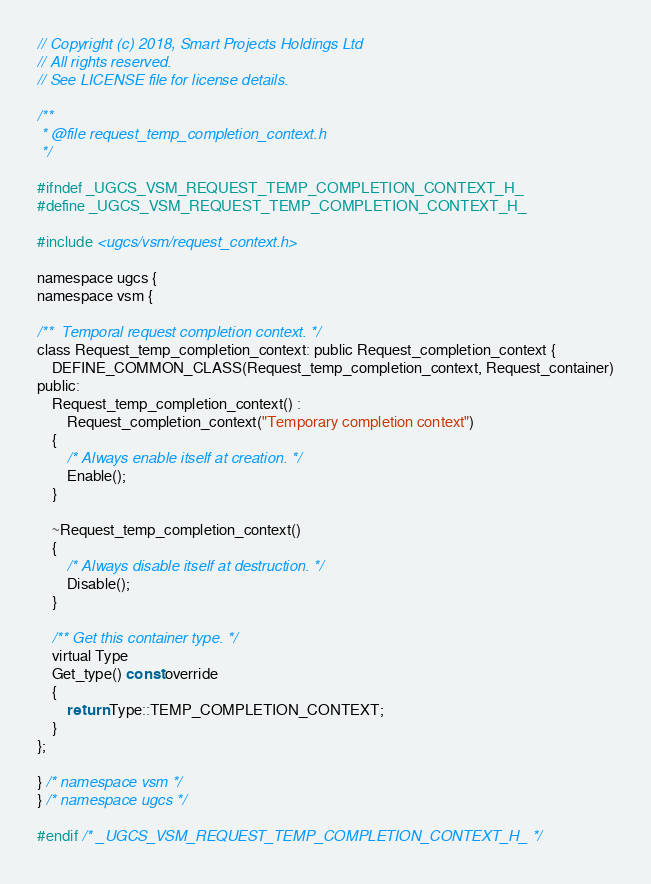Convert code to text. <code><loc_0><loc_0><loc_500><loc_500><_C_>// Copyright (c) 2018, Smart Projects Holdings Ltd
// All rights reserved.
// See LICENSE file for license details.

/**
 * @file request_temp_completion_context.h
 */

#ifndef _UGCS_VSM_REQUEST_TEMP_COMPLETION_CONTEXT_H_
#define _UGCS_VSM_REQUEST_TEMP_COMPLETION_CONTEXT_H_

#include <ugcs/vsm/request_context.h>

namespace ugcs {
namespace vsm {

/**  Temporal request completion context. */
class Request_temp_completion_context: public Request_completion_context {
    DEFINE_COMMON_CLASS(Request_temp_completion_context, Request_container)
public:
    Request_temp_completion_context() :
        Request_completion_context("Temporary completion context")
    {
        /* Always enable itself at creation. */
        Enable();
    }

    ~Request_temp_completion_context()
    {
        /* Always disable itself at destruction. */
        Disable();
    }

    /** Get this container type. */
    virtual Type
    Get_type() const override
    {
        return Type::TEMP_COMPLETION_CONTEXT;
    }
};

} /* namespace vsm */
} /* namespace ugcs */

#endif /* _UGCS_VSM_REQUEST_TEMP_COMPLETION_CONTEXT_H_ */
</code> 